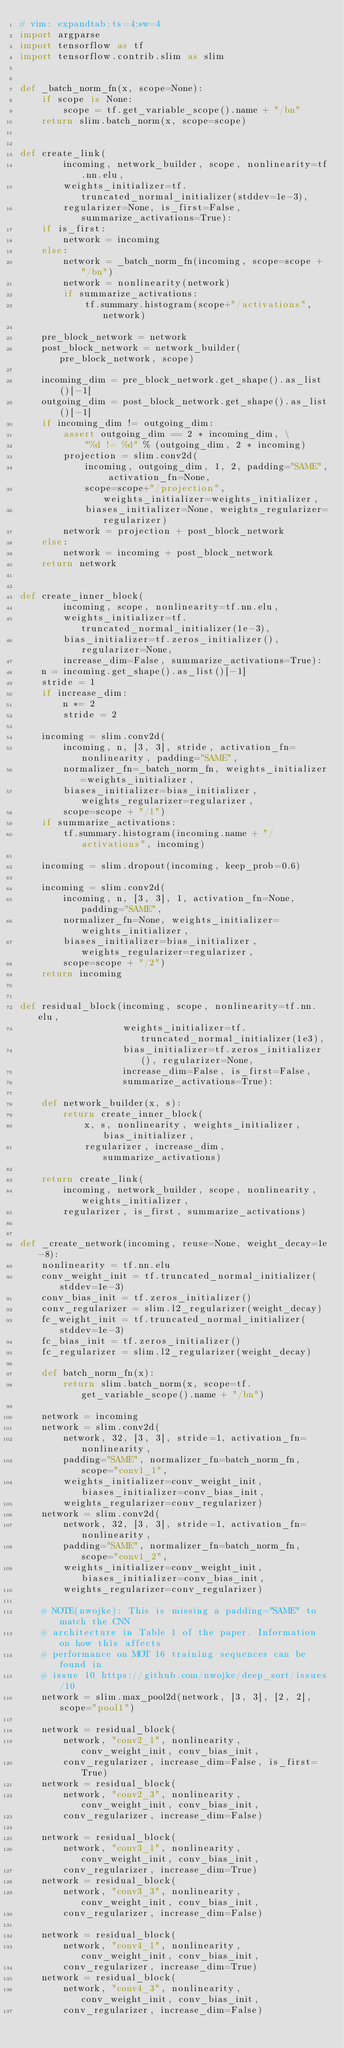Convert code to text. <code><loc_0><loc_0><loc_500><loc_500><_Python_># vim: expandtab:ts=4:sw=4
import argparse
import tensorflow as tf
import tensorflow.contrib.slim as slim


def _batch_norm_fn(x, scope=None):
    if scope is None:
        scope = tf.get_variable_scope().name + "/bn"
    return slim.batch_norm(x, scope=scope)


def create_link(
        incoming, network_builder, scope, nonlinearity=tf.nn.elu,
        weights_initializer=tf.truncated_normal_initializer(stddev=1e-3),
        regularizer=None, is_first=False, summarize_activations=True):
    if is_first:
        network = incoming
    else:
        network = _batch_norm_fn(incoming, scope=scope + "/bn")
        network = nonlinearity(network)
        if summarize_activations:
            tf.summary.histogram(scope+"/activations", network)

    pre_block_network = network
    post_block_network = network_builder(pre_block_network, scope)

    incoming_dim = pre_block_network.get_shape().as_list()[-1]
    outgoing_dim = post_block_network.get_shape().as_list()[-1]
    if incoming_dim != outgoing_dim:
        assert outgoing_dim == 2 * incoming_dim, \
            "%d != %d" % (outgoing_dim, 2 * incoming)
        projection = slim.conv2d(
            incoming, outgoing_dim, 1, 2, padding="SAME", activation_fn=None,
            scope=scope+"/projection", weights_initializer=weights_initializer,
            biases_initializer=None, weights_regularizer=regularizer)
        network = projection + post_block_network
    else:
        network = incoming + post_block_network
    return network


def create_inner_block(
        incoming, scope, nonlinearity=tf.nn.elu,
        weights_initializer=tf.truncated_normal_initializer(1e-3),
        bias_initializer=tf.zeros_initializer(), regularizer=None,
        increase_dim=False, summarize_activations=True):
    n = incoming.get_shape().as_list()[-1]
    stride = 1
    if increase_dim:
        n *= 2
        stride = 2

    incoming = slim.conv2d(
        incoming, n, [3, 3], stride, activation_fn=nonlinearity, padding="SAME",
        normalizer_fn=_batch_norm_fn, weights_initializer=weights_initializer,
        biases_initializer=bias_initializer, weights_regularizer=regularizer,
        scope=scope + "/1")
    if summarize_activations:
        tf.summary.histogram(incoming.name + "/activations", incoming)

    incoming = slim.dropout(incoming, keep_prob=0.6)

    incoming = slim.conv2d(
        incoming, n, [3, 3], 1, activation_fn=None, padding="SAME",
        normalizer_fn=None, weights_initializer=weights_initializer,
        biases_initializer=bias_initializer, weights_regularizer=regularizer,
        scope=scope + "/2")
    return incoming


def residual_block(incoming, scope, nonlinearity=tf.nn.elu,
                   weights_initializer=tf.truncated_normal_initializer(1e3),
                   bias_initializer=tf.zeros_initializer(), regularizer=None,
                   increase_dim=False, is_first=False,
                   summarize_activations=True):

    def network_builder(x, s):
        return create_inner_block(
            x, s, nonlinearity, weights_initializer, bias_initializer,
            regularizer, increase_dim, summarize_activations)

    return create_link(
        incoming, network_builder, scope, nonlinearity, weights_initializer,
        regularizer, is_first, summarize_activations)


def _create_network(incoming, reuse=None, weight_decay=1e-8):
    nonlinearity = tf.nn.elu
    conv_weight_init = tf.truncated_normal_initializer(stddev=1e-3)
    conv_bias_init = tf.zeros_initializer()
    conv_regularizer = slim.l2_regularizer(weight_decay)
    fc_weight_init = tf.truncated_normal_initializer(stddev=1e-3)
    fc_bias_init = tf.zeros_initializer()
    fc_regularizer = slim.l2_regularizer(weight_decay)

    def batch_norm_fn(x):
        return slim.batch_norm(x, scope=tf.get_variable_scope().name + "/bn")

    network = incoming
    network = slim.conv2d(
        network, 32, [3, 3], stride=1, activation_fn=nonlinearity,
        padding="SAME", normalizer_fn=batch_norm_fn, scope="conv1_1",
        weights_initializer=conv_weight_init, biases_initializer=conv_bias_init,
        weights_regularizer=conv_regularizer)
    network = slim.conv2d(
        network, 32, [3, 3], stride=1, activation_fn=nonlinearity,
        padding="SAME", normalizer_fn=batch_norm_fn, scope="conv1_2",
        weights_initializer=conv_weight_init, biases_initializer=conv_bias_init,
        weights_regularizer=conv_regularizer)

    # NOTE(nwojke): This is missing a padding="SAME" to match the CNN
    # architecture in Table 1 of the paper. Information on how this affects
    # performance on MOT 16 training sequences can be found in
    # issue 10 https://github.com/nwojke/deep_sort/issues/10
    network = slim.max_pool2d(network, [3, 3], [2, 2], scope="pool1")

    network = residual_block(
        network, "conv2_1", nonlinearity, conv_weight_init, conv_bias_init,
        conv_regularizer, increase_dim=False, is_first=True)
    network = residual_block(
        network, "conv2_3", nonlinearity, conv_weight_init, conv_bias_init,
        conv_regularizer, increase_dim=False)

    network = residual_block(
        network, "conv3_1", nonlinearity, conv_weight_init, conv_bias_init,
        conv_regularizer, increase_dim=True)
    network = residual_block(
        network, "conv3_3", nonlinearity, conv_weight_init, conv_bias_init,
        conv_regularizer, increase_dim=False)

    network = residual_block(
        network, "conv4_1", nonlinearity, conv_weight_init, conv_bias_init,
        conv_regularizer, increase_dim=True)
    network = residual_block(
        network, "conv4_3", nonlinearity, conv_weight_init, conv_bias_init,
        conv_regularizer, increase_dim=False)
</code> 